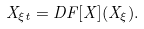<formula> <loc_0><loc_0><loc_500><loc_500>X _ { \xi t } = D F [ X ] ( X _ { \xi } ) .</formula> 